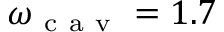Convert formula to latex. <formula><loc_0><loc_0><loc_500><loc_500>\omega _ { c a v } = 1 . 7</formula> 